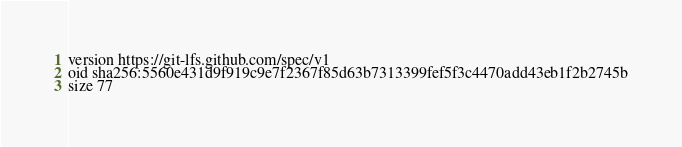<code> <loc_0><loc_0><loc_500><loc_500><_YAML_>version https://git-lfs.github.com/spec/v1
oid sha256:5560e431d9f919c9e7f2367f85d63b7313399fef5f3c4470add43eb1f2b2745b
size 77
</code> 